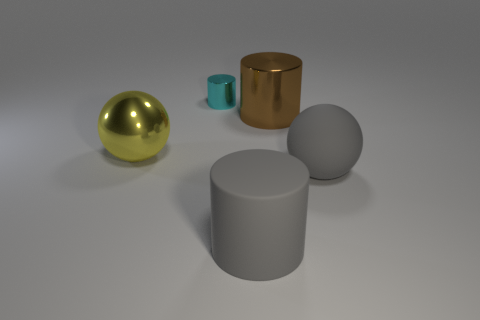Subtract all cyan cylinders. How many cylinders are left? 2 Add 1 tiny blue rubber objects. How many objects exist? 6 Subtract all cylinders. How many objects are left? 2 Subtract all blue cylinders. Subtract all red balls. How many cylinders are left? 3 Subtract all green cubes. How many yellow spheres are left? 1 Subtract all large gray matte balls. Subtract all big yellow balls. How many objects are left? 3 Add 1 big matte cylinders. How many big matte cylinders are left? 2 Add 2 large yellow shiny cubes. How many large yellow shiny cubes exist? 2 Subtract all brown cylinders. How many cylinders are left? 2 Subtract 0 gray blocks. How many objects are left? 5 